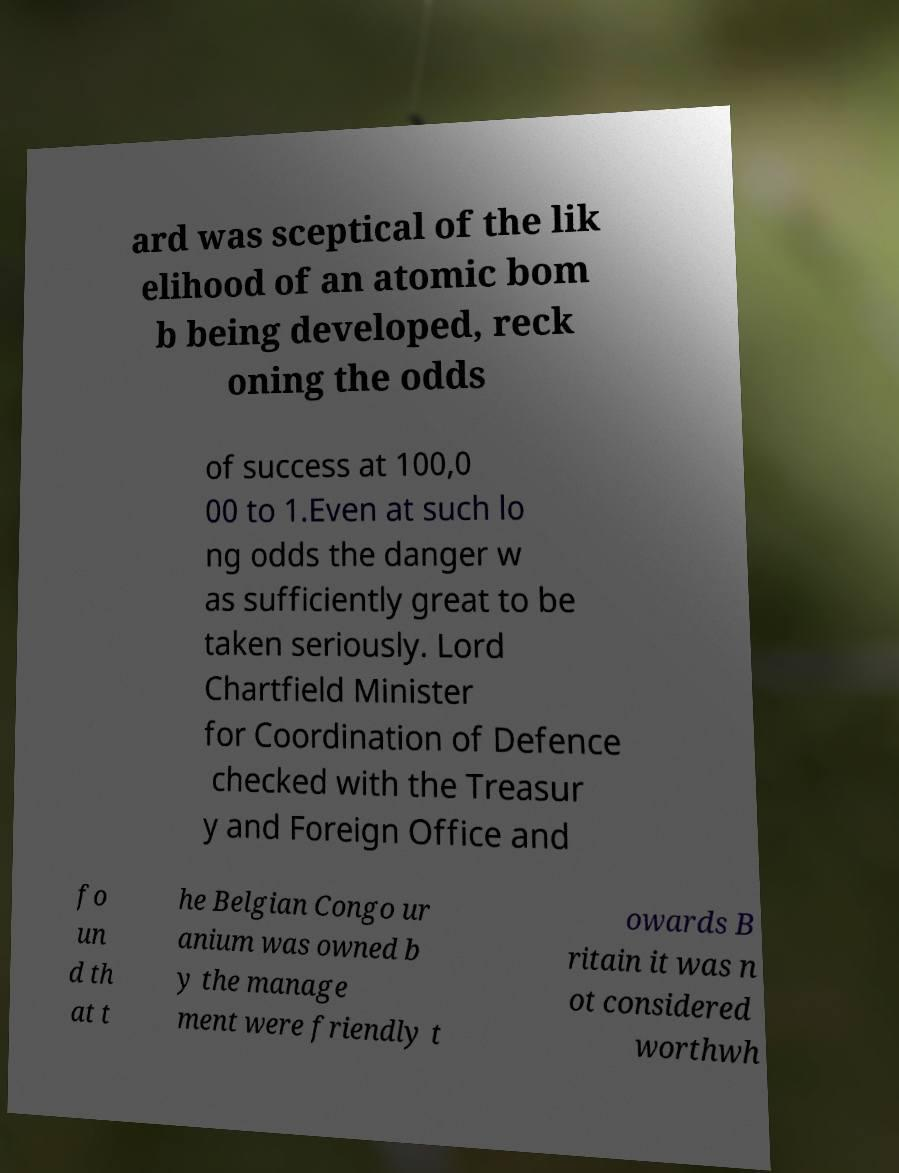What messages or text are displayed in this image? I need them in a readable, typed format. ard was sceptical of the lik elihood of an atomic bom b being developed, reck oning the odds of success at 100,0 00 to 1.Even at such lo ng odds the danger w as sufficiently great to be taken seriously. Lord Chartfield Minister for Coordination of Defence checked with the Treasur y and Foreign Office and fo un d th at t he Belgian Congo ur anium was owned b y the manage ment were friendly t owards B ritain it was n ot considered worthwh 